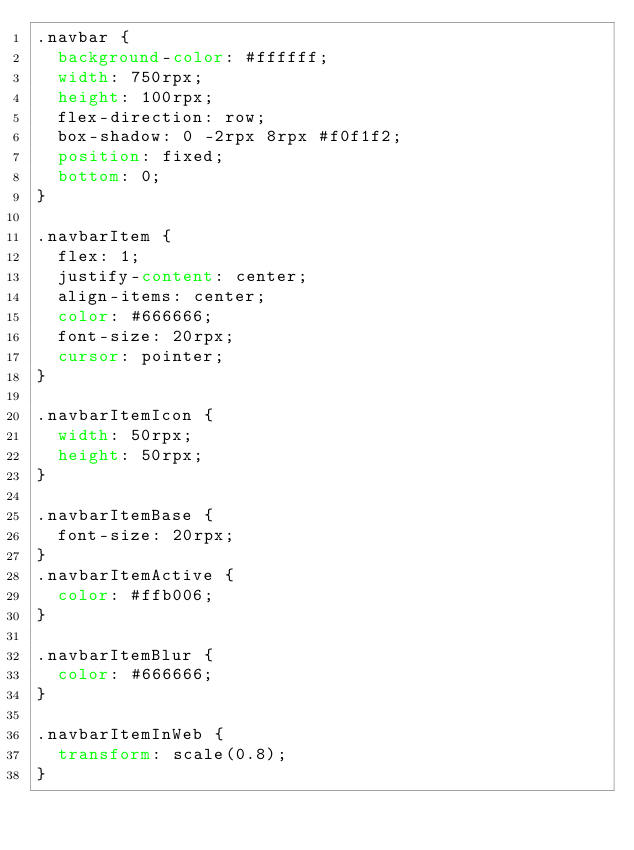<code> <loc_0><loc_0><loc_500><loc_500><_CSS_>.navbar {
  background-color: #ffffff;
  width: 750rpx;
  height: 100rpx;
  flex-direction: row;
  box-shadow: 0 -2rpx 8rpx #f0f1f2;
  position: fixed;
  bottom: 0;
}

.navbarItem {
  flex: 1;
  justify-content: center;
  align-items: center;
  color: #666666;
  font-size: 20rpx;
  cursor: pointer;
}

.navbarItemIcon {
  width: 50rpx;
  height: 50rpx;
}

.navbarItemBase {
  font-size: 20rpx;
}
.navbarItemActive {
  color: #ffb006;
}

.navbarItemBlur {
  color: #666666;
}

.navbarItemInWeb {
  transform: scale(0.8);
}
</code> 